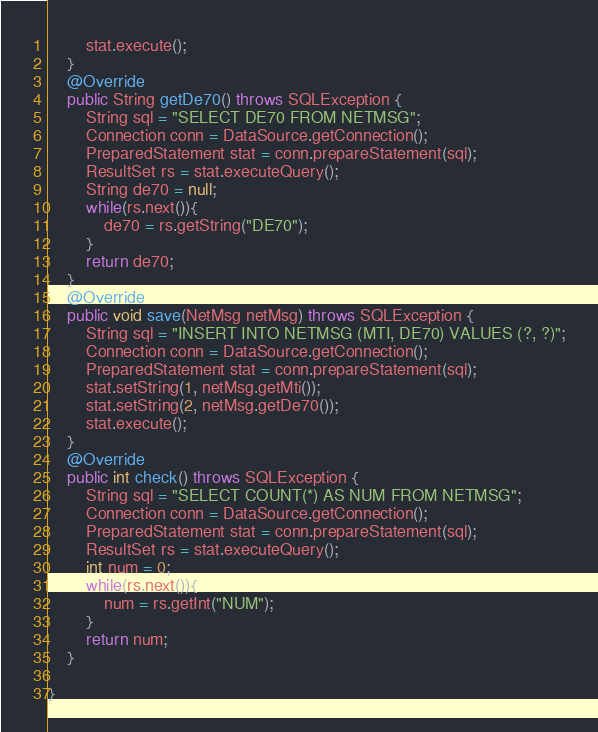Convert code to text. <code><loc_0><loc_0><loc_500><loc_500><_Java_>		stat.execute();
	}
	@Override
	public String getDe70() throws SQLException {
		String sql = "SELECT DE70 FROM NETMSG";
		Connection conn = DataSource.getConnection();
		PreparedStatement stat = conn.prepareStatement(sql);
		ResultSet rs = stat.executeQuery();
		String de70 = null;
		while(rs.next()){
			de70 = rs.getString("DE70");
		}
		return de70;
	}
	@Override
	public void save(NetMsg netMsg) throws SQLException {
		String sql = "INSERT INTO NETMSG (MTI, DE70) VALUES (?, ?)";
		Connection conn = DataSource.getConnection();
		PreparedStatement stat = conn.prepareStatement(sql);
		stat.setString(1, netMsg.getMti());
		stat.setString(2, netMsg.getDe70());
		stat.execute();
	}
	@Override
	public int check() throws SQLException {
		String sql = "SELECT COUNT(*) AS NUM FROM NETMSG";
		Connection conn = DataSource.getConnection();
		PreparedStatement stat = conn.prepareStatement(sql);
		ResultSet rs = stat.executeQuery();
		int num = 0;
		while(rs.next()){
			num = rs.getInt("NUM");
		}
		return num;
	}
	
}
</code> 